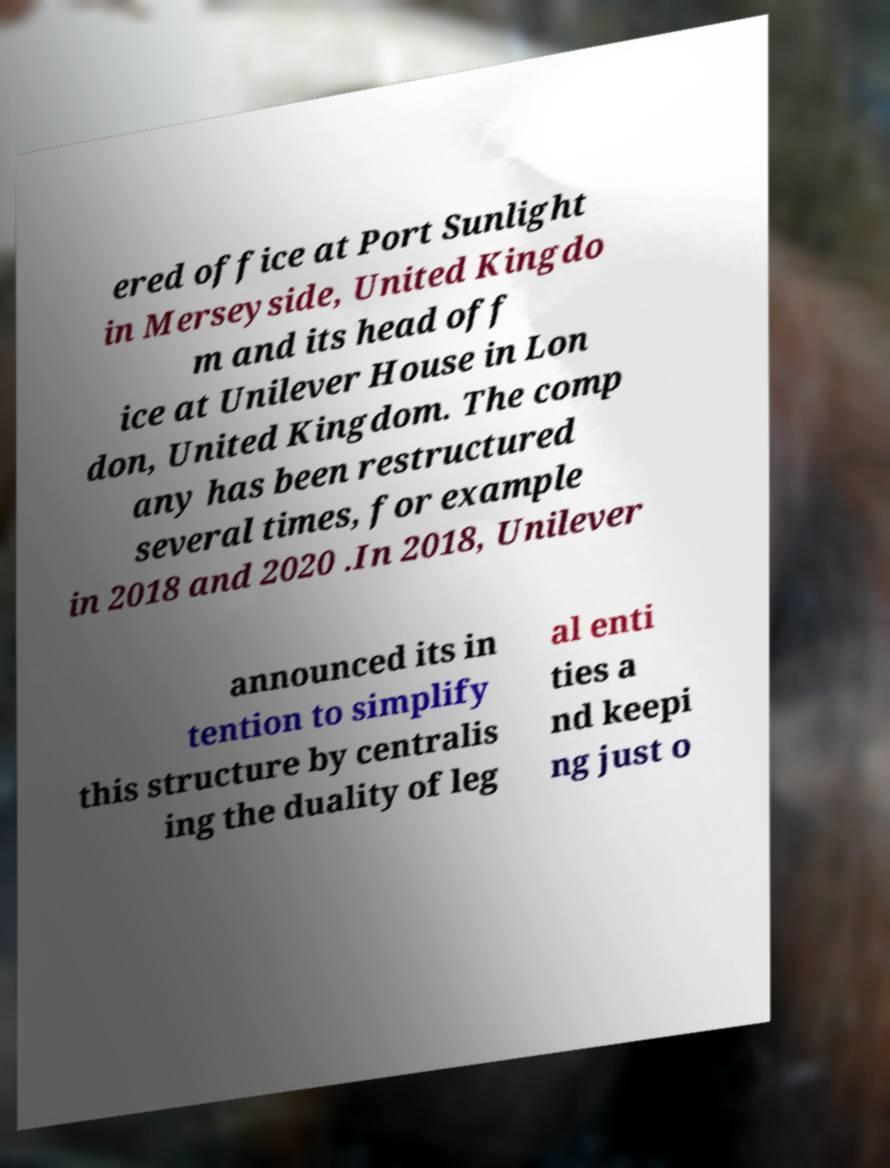I need the written content from this picture converted into text. Can you do that? ered office at Port Sunlight in Merseyside, United Kingdo m and its head off ice at Unilever House in Lon don, United Kingdom. The comp any has been restructured several times, for example in 2018 and 2020 .In 2018, Unilever announced its in tention to simplify this structure by centralis ing the duality of leg al enti ties a nd keepi ng just o 